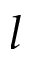<formula> <loc_0><loc_0><loc_500><loc_500>l</formula> 